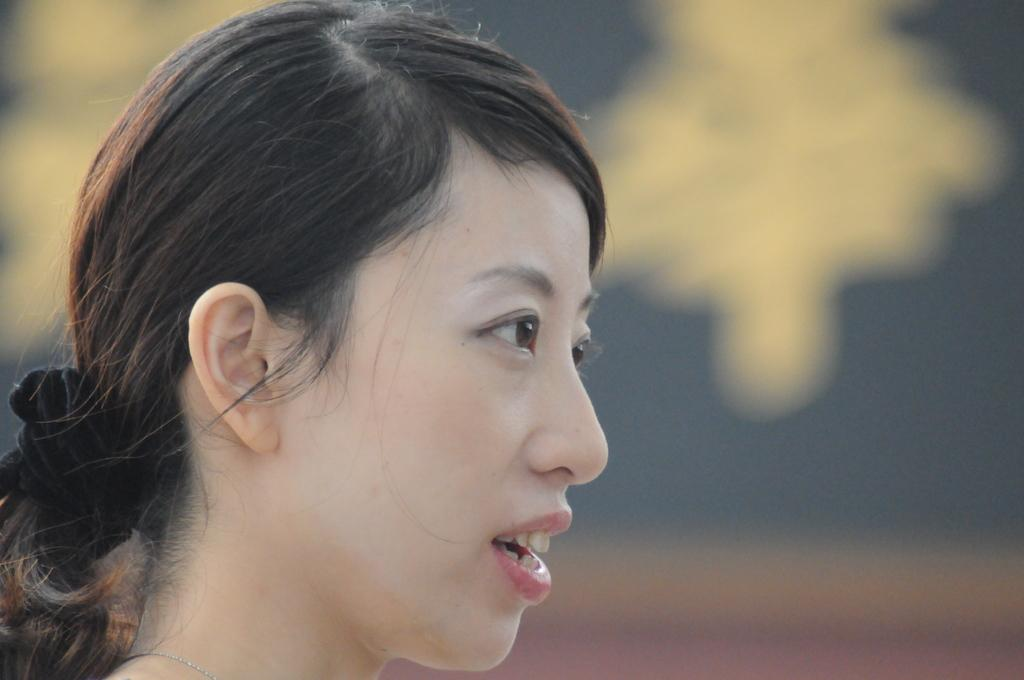What is the main subject of the image? There is a person's face in the main subject of the image. Can you describe the background of the image? The background is blurred. What type of marble is being polished by the servant in the image? There is no marble or servant present in the image; it only features a person's face with a blurred background. 